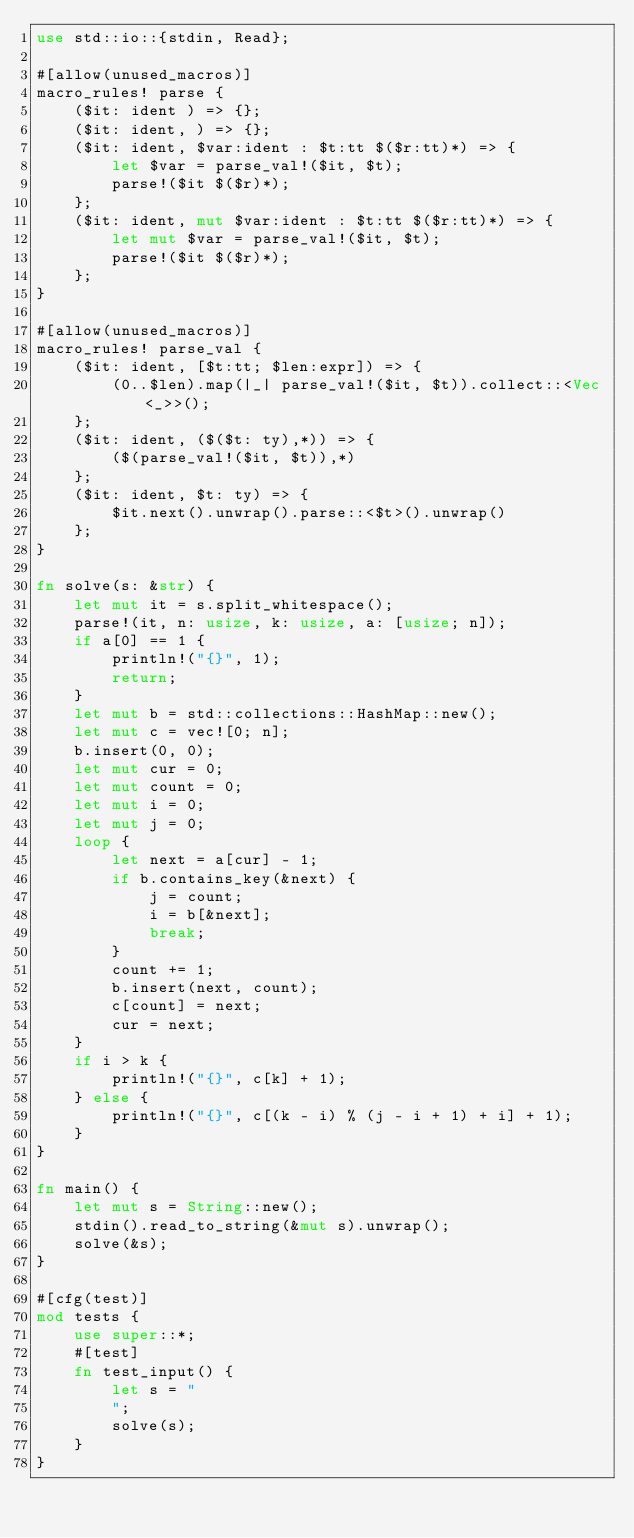Convert code to text. <code><loc_0><loc_0><loc_500><loc_500><_Rust_>use std::io::{stdin, Read};

#[allow(unused_macros)]
macro_rules! parse {
    ($it: ident ) => {};
    ($it: ident, ) => {};
    ($it: ident, $var:ident : $t:tt $($r:tt)*) => {
        let $var = parse_val!($it, $t);
        parse!($it $($r)*);
    };
    ($it: ident, mut $var:ident : $t:tt $($r:tt)*) => {
        let mut $var = parse_val!($it, $t);
        parse!($it $($r)*);
    };
}

#[allow(unused_macros)]
macro_rules! parse_val {
    ($it: ident, [$t:tt; $len:expr]) => {
        (0..$len).map(|_| parse_val!($it, $t)).collect::<Vec<_>>();
    };
    ($it: ident, ($($t: ty),*)) => {
        ($(parse_val!($it, $t)),*)
    };
    ($it: ident, $t: ty) => {
        $it.next().unwrap().parse::<$t>().unwrap()
    };
}

fn solve(s: &str) {
    let mut it = s.split_whitespace();
    parse!(it, n: usize, k: usize, a: [usize; n]);
    if a[0] == 1 {
        println!("{}", 1);
        return;
    }
    let mut b = std::collections::HashMap::new();
    let mut c = vec![0; n];
    b.insert(0, 0);
    let mut cur = 0;
    let mut count = 0;
    let mut i = 0;
    let mut j = 0;
    loop {
        let next = a[cur] - 1;
        if b.contains_key(&next) {
            j = count;
            i = b[&next];
            break;
        }
        count += 1;
        b.insert(next, count);
        c[count] = next;
        cur = next;
    }
    if i > k {
        println!("{}", c[k] + 1);
    } else {
        println!("{}", c[(k - i) % (j - i + 1) + i] + 1);
    }
}

fn main() {
    let mut s = String::new();
    stdin().read_to_string(&mut s).unwrap();
    solve(&s);
}

#[cfg(test)]
mod tests {
    use super::*;
    #[test]
    fn test_input() {
        let s = "
        ";
        solve(s);
    }
}
</code> 